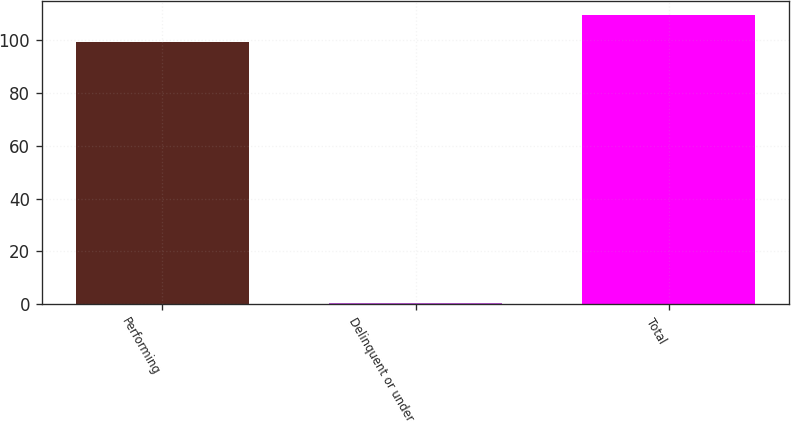<chart> <loc_0><loc_0><loc_500><loc_500><bar_chart><fcel>Performing<fcel>Delinquent or under<fcel>Total<nl><fcel>99.4<fcel>0.5<fcel>109.35<nl></chart> 